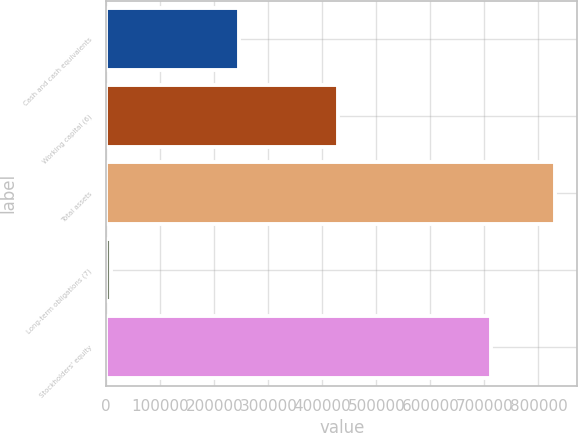<chart> <loc_0><loc_0><loc_500><loc_500><bar_chart><fcel>Cash and cash equivalents<fcel>Working capital (6)<fcel>Total assets<fcel>Long-term obligations (7)<fcel>Stockholders' equity<nl><fcel>245027<fcel>429277<fcel>830479<fcel>9012<fcel>712129<nl></chart> 